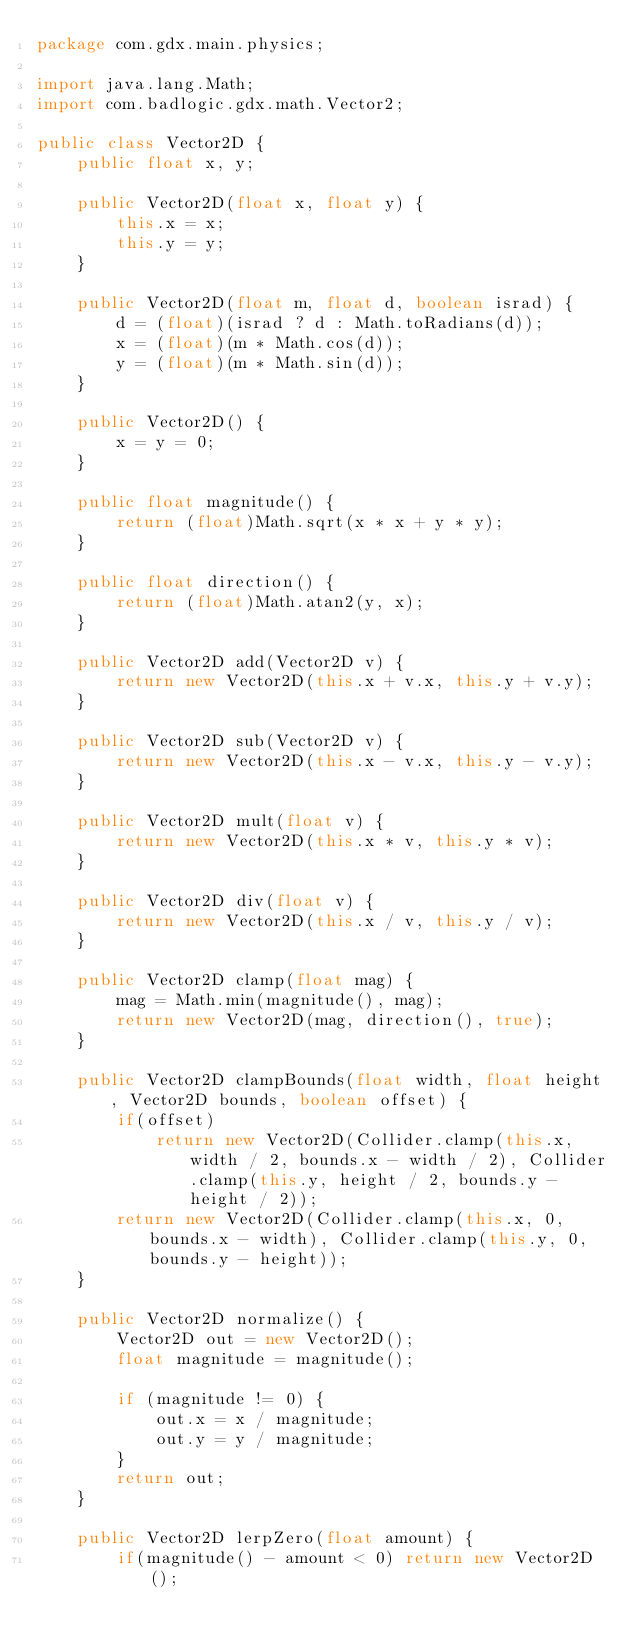<code> <loc_0><loc_0><loc_500><loc_500><_Java_>package com.gdx.main.physics;

import java.lang.Math;
import com.badlogic.gdx.math.Vector2;

public class Vector2D {
	public float x, y;
	
	public Vector2D(float x, float y) {
		this.x = x;
		this.y = y;
	}
	
	public Vector2D(float m, float d, boolean israd) {
		d = (float)(israd ? d : Math.toRadians(d));
		x = (float)(m * Math.cos(d));
		y = (float)(m * Math.sin(d));
	}
	
	public Vector2D() {
		x = y = 0;
	}

	public float magnitude() {
		return (float)Math.sqrt(x * x + y * y);
	}
	
	public float direction() {
		return (float)Math.atan2(y, x);
	}

	public Vector2D add(Vector2D v) {
		return new Vector2D(this.x + v.x, this.y + v.y);
	}

	public Vector2D sub(Vector2D v) {
		return new Vector2D(this.x - v.x, this.y - v.y);
	}
	
	public Vector2D mult(float v) {
		return new Vector2D(this.x * v, this.y * v);
	}
	
	public Vector2D div(float v) {
		return new Vector2D(this.x / v, this.y / v);
	}
	
	public Vector2D clamp(float mag) {
		mag = Math.min(magnitude(), mag);
		return new Vector2D(mag, direction(), true);
	}
	
	public Vector2D clampBounds(float width, float height, Vector2D bounds, boolean offset) {
		if(offset)
			return new Vector2D(Collider.clamp(this.x, width / 2, bounds.x - width / 2), Collider.clamp(this.y, height / 2, bounds.y - height / 2));
		return new Vector2D(Collider.clamp(this.x, 0, bounds.x - width), Collider.clamp(this.y, 0, bounds.y - height));
	}

	public Vector2D normalize() {
		Vector2D out = new Vector2D();
		float magnitude = magnitude();
		
		if (magnitude != 0) {
	        out.x = x / magnitude;
	        out.y = y / magnitude;
		}
	    return out;
	}

	public Vector2D lerpZero(float amount) {
		if(magnitude() - amount < 0) return new Vector2D();</code> 